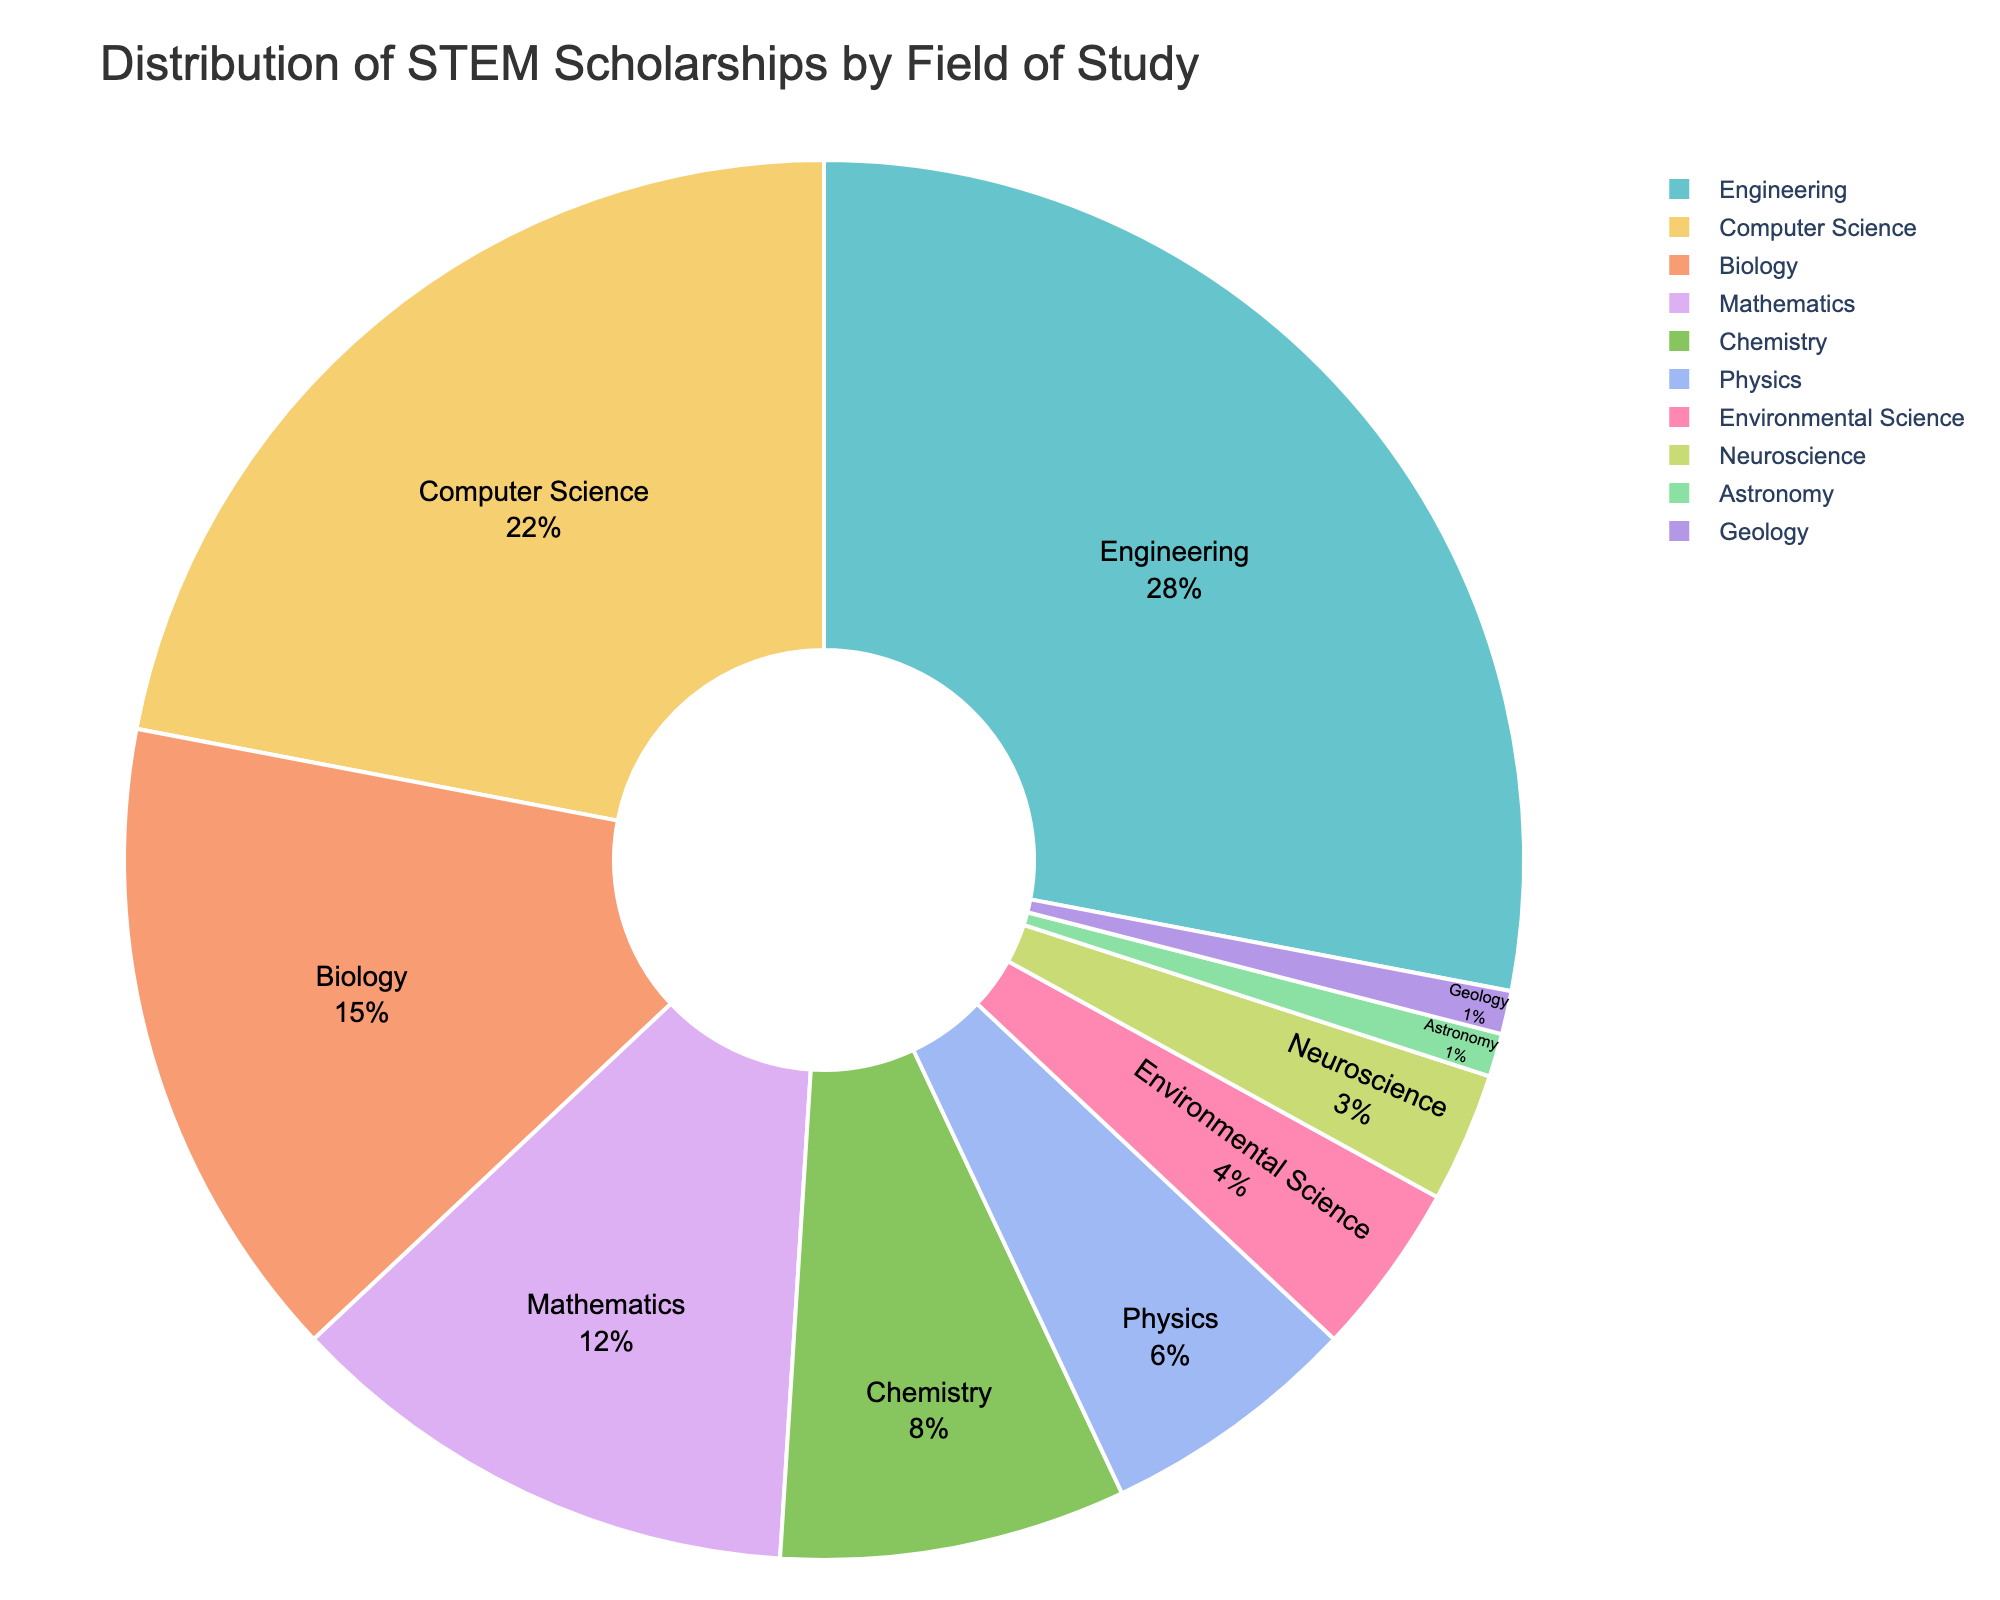Which field has the highest percentage of STEM scholarships? The largest segment of the pie chart will be the field with the highest percentage. Based on the provided data, Engineering has the highest percentage of STEM scholarships at 28%.
Answer: Engineering Which fields have an equal percentage of STEM scholarships? Look for segments of the pie chart that represent the same size and check their labels. According to the data, both Astronomy and Geology have the same percentage of 1% each.
Answer: Astronomy and Geology What is the combined percentage of scholarships for Physics and Chemistry? Sum the individual percentages for Physics (6%) and Chemistry (8%). 6% + 8% = 14%.
Answer: 14% Which field has a higher percentage of scholarships, Biology or Mathematics? Compare the percentages for Biology (15%) and Mathematics (12%). Since 15% is greater than 12%, Biology has a higher percentage of scholarships.
Answer: Biology What percentage of scholarships goes to Environmental Science? Identify the segment labeled "Environmental Science" and note its percentage. According to the data, Environmental Science has 4% of the scholarships.
Answer: 4% How does the percentage for Computer Science compare to the average percentage of all fields? Calculate the average percentage first. Sum all the percentages and divide by the number of fields: (28% + 22% + 15% + 12% + 8% + 6% + 4% + 3% + 1% + 1%) / 10 = 10%. Compare this average with Computer Science's percentage, which is 22%. Since 22% > 10%, Computer Science is above the average.
Answer: Higher than the average What is the total percentage for scholarships in the top three fields? Identify the top three fields by percentage: Engineering (28%), Computer Science (22%), and Biology (15%). Sum these percentages: 28% + 22% + 15% = 65%.
Answer: 65% Which field, Environmental Science or Neuroscience, has fewer scholarships? Compare the percentages of Environmental Science (4%) and Neuroscience (3%). Since 3% is less than 4%, Neuroscience has fewer scholarships.
Answer: Neuroscience 